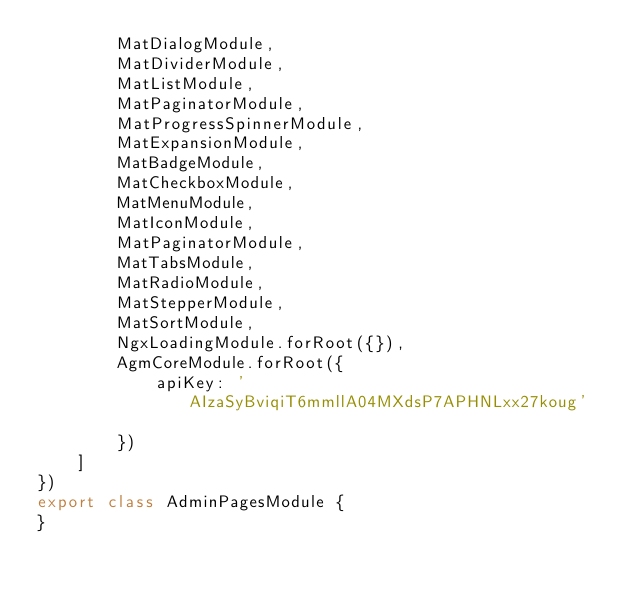Convert code to text. <code><loc_0><loc_0><loc_500><loc_500><_TypeScript_>        MatDialogModule,
        MatDividerModule,
        MatListModule,
        MatPaginatorModule,
        MatProgressSpinnerModule,
        MatExpansionModule,
        MatBadgeModule,
        MatCheckboxModule,
        MatMenuModule,
        MatIconModule,
        MatPaginatorModule,
        MatTabsModule,
        MatRadioModule,
        MatStepperModule,
        MatSortModule,
        NgxLoadingModule.forRoot({}),
        AgmCoreModule.forRoot({
            apiKey: 'AIzaSyBviqiT6mmllA04MXdsP7APHNLxx27koug'

        })
    ]
})
export class AdminPagesModule {
}
</code> 